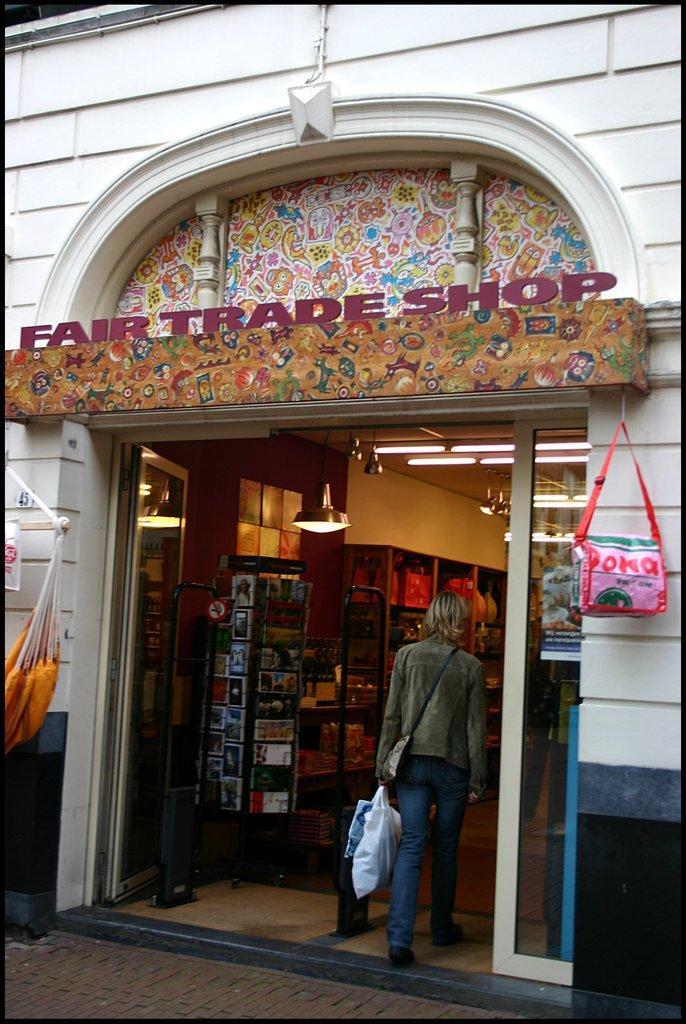Could you give a brief overview of what you see in this image? There is a fair trade shop where a woman is entering into it. 